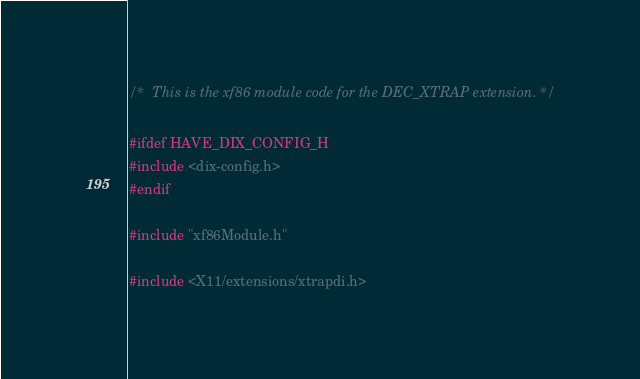<code> <loc_0><loc_0><loc_500><loc_500><_C_>/*  This is the xf86 module code for the DEC_XTRAP extension. */

#ifdef HAVE_DIX_CONFIG_H
#include <dix-config.h>
#endif

#include "xf86Module.h"

#include <X11/extensions/xtrapdi.h>
</code> 